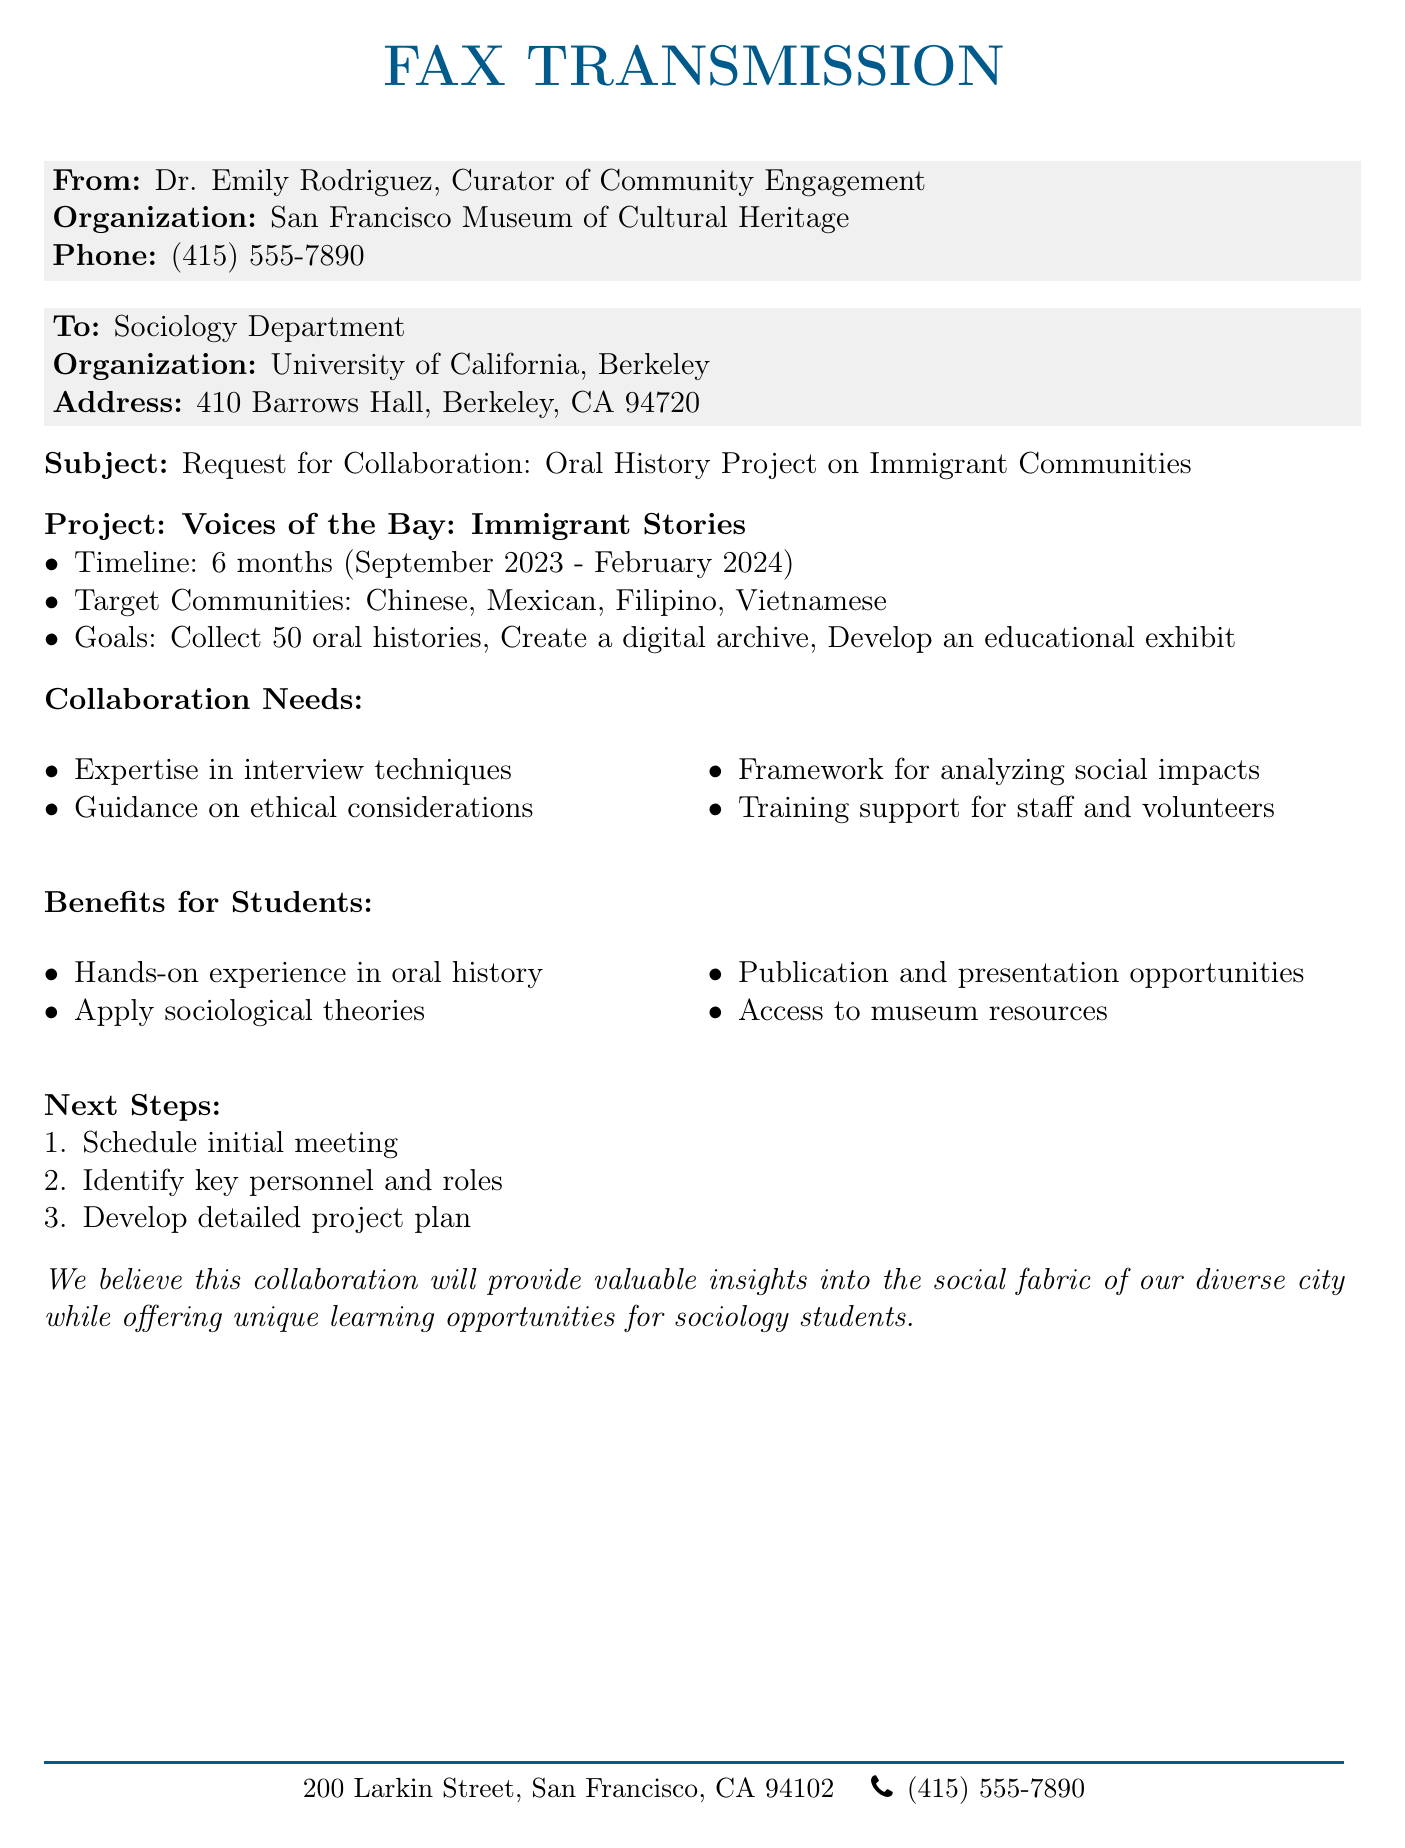What is the name of the project? The project is named "Voices of the Bay: Immigrant Stories."
Answer: Voices of the Bay: Immigrant Stories Who is the sender of the fax? The sender of the fax is Dr. Emily Rodriguez.
Answer: Dr. Emily Rodriguez What is the timeline for the project? The timeline for the project is six months from September 2023 to February 2024.
Answer: 6 months (September 2023 - February 2024) How many oral histories are targeted for collection? The goal is to collect 50 oral histories.
Answer: 50 Which communities are targeted in the project? The targeted communities are Chinese, Mexican, Filipino, and Vietnamese.
Answer: Chinese, Mexican, Filipino, Vietnamese What kind of experience will students gain? Students will gain hands-on experience in oral history.
Answer: Hands-on experience in oral history What is one of the collaboration needs listed? One of the collaboration needs is expertise in interview techniques.
Answer: Expertise in interview techniques What is the first next step outlined in the document? The first next step is to schedule an initial meeting.
Answer: Schedule initial meeting Where is the organization located? The organization is located at 200 Larkin Street, San Francisco, CA 94102.
Answer: 200 Larkin Street, San Francisco, CA 94102 